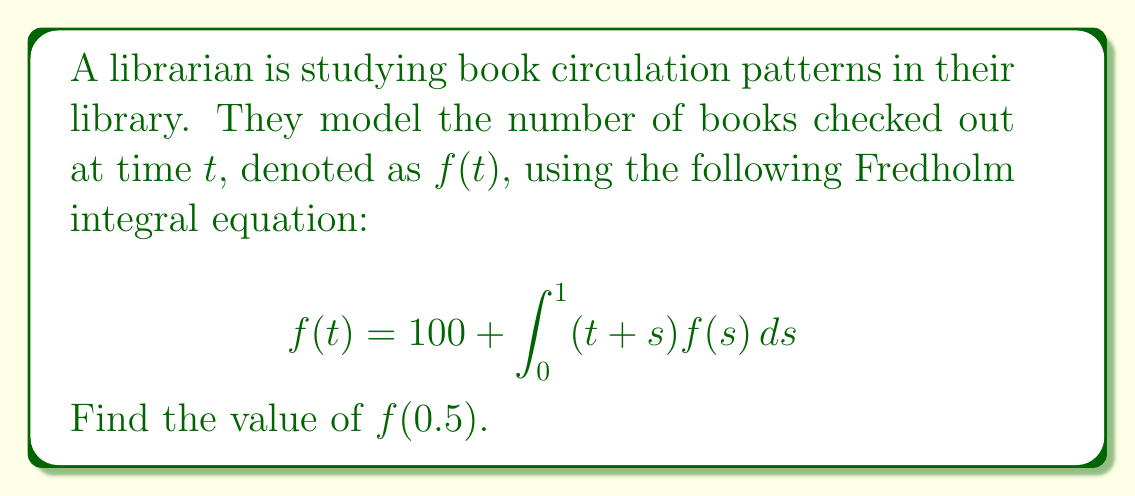Give your solution to this math problem. To solve this Fredholm integral equation, we'll follow these steps:

1) First, we assume that $f(t)$ is a polynomial function. Given the form of the equation, let's try $f(t) = a + bt$.

2) Substitute this into the original equation:

   $$a + bt = 100 + \int_0^1 (t+s)(a + bs)ds$$

3) Expand the right-hand side:

   $$a + bt = 100 + \int_0^1 (at + as + bst + bs^2)ds$$

4) Integrate:

   $$a + bt = 100 + at + \frac{a}{2} + \frac{bt}{2} + \frac{b}{3}$$

5) Collect like terms:

   $$a + bt = 100 + at + \frac{a}{2} + \frac{bt}{2} + \frac{b}{3}$$
   $$\frac{a}{2} + \frac{bt}{2} = 100 + \frac{b}{3}$$

6) For this equation to be true for all $t$, the coefficients of $t$ on both sides must be equal, and the constant terms must be equal:

   $$\frac{b}{2} = 0$$
   $$\frac{a}{2} = 100 + \frac{b}{3}$$

7) From the first equation, we get $b = 0$. Substituting this into the second equation:

   $$\frac{a}{2} = 100$$
   $$a = 200$$

8) Therefore, $f(t) = 200$ for all $t$.

9) To find $f(0.5)$, we simply substitute $t = 0.5$:

   $$f(0.5) = 200$$
Answer: 200 